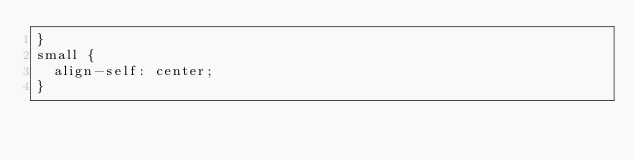Convert code to text. <code><loc_0><loc_0><loc_500><loc_500><_CSS_>}
small {
  align-self: center;
}
</code> 